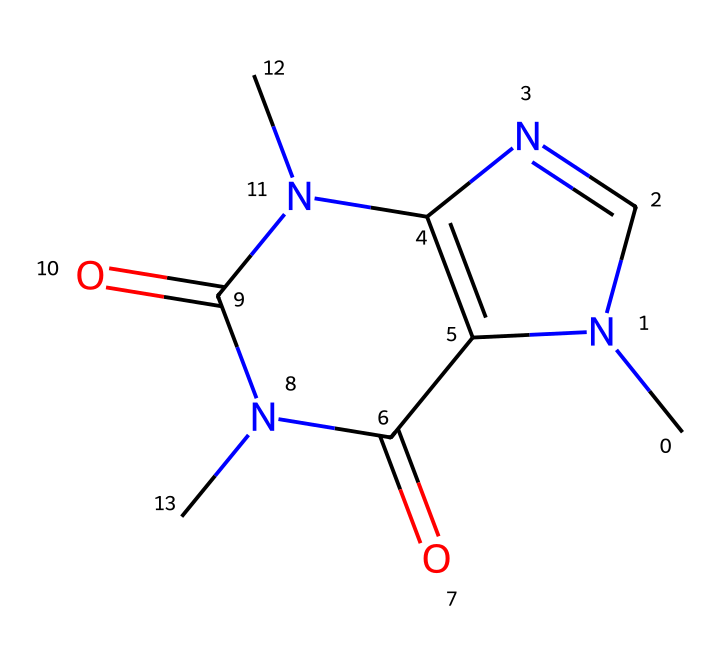What is the molecular formula of caffeine? The molecular formula can be derived from the number of carbon (C), hydrogen (H), nitrogen (N), and oxygen (O) atoms in the structure. In this case, there are 8 carbon atoms, 10 hydrogen atoms, 4 nitrogen atoms, and 2 oxygen atoms, resulting in the formula C8H10N4O2.
Answer: C8H10N4O2 How many rings are present in the structure of caffeine? The structure contains two fused rings, a characteristic feature of caffeine. This can be observed visually from the cyclic portions of the molecule.
Answer: 2 How many nitrogen atoms are in caffeine? By counting the nitrogen (N) atom symbols in the SMILES representation, we can see that there are four nitrogen atoms present.
Answer: 4 What type of substance is caffeine classified as? Caffeine is classified as a stimulant due to its ability to increase alertness and reduce fatigue. This classification is common for compounds that affect the central nervous system.
Answer: stimulant What is the key effect of caffeine commonly experienced when consumed? The primary effect of caffeine is increased alertness, often leading to enhanced concentration and focus, making it popular among those who consume it during games.
Answer: increased alertness What is the main reason caffeine is included in energy drinks? Caffeine is included in energy drinks primarily for its stimulating effects, which help improve endurance and physical performance during activities like watching a game.
Answer: stimulating effects 